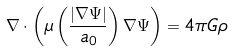Convert formula to latex. <formula><loc_0><loc_0><loc_500><loc_500>\nabla \cdot \left ( \mu \left ( \frac { | \nabla \Psi | } { a _ { 0 } } \right ) \nabla \Psi \right ) = 4 \pi G \rho</formula> 